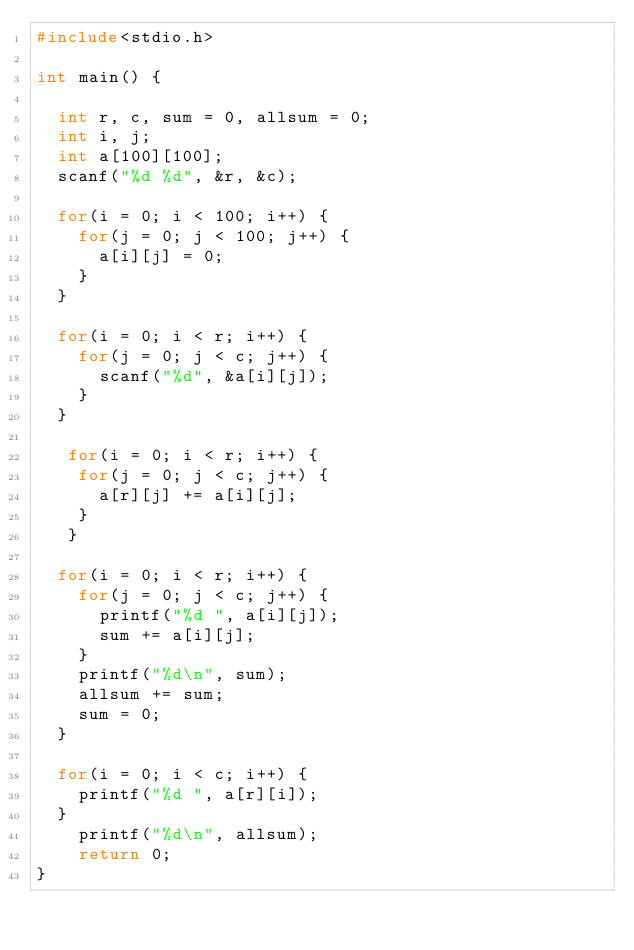Convert code to text. <code><loc_0><loc_0><loc_500><loc_500><_C_>#include<stdio.h>

int main() {

  int r, c, sum = 0, allsum = 0;
  int i, j;
  int a[100][100];
  scanf("%d %d", &r, &c);

  for(i = 0; i < 100; i++) {
    for(j = 0; j < 100; j++) {
      a[i][j] = 0;
    }
  }

  for(i = 0; i < r; i++) {
    for(j = 0; j < c; j++) {
      scanf("%d", &a[i][j]);
    }
  }

   for(i = 0; i < r; i++) {
    for(j = 0; j < c; j++) {
      a[r][j] += a[i][j];
    }
   }

  for(i = 0; i < r; i++) {
    for(j = 0; j < c; j++) {
      printf("%d ", a[i][j]);
      sum += a[i][j];
    }
    printf("%d\n", sum);
    allsum += sum;
    sum = 0;
  }

  for(i = 0; i < c; i++) {
    printf("%d ", a[r][i]);
  }
    printf("%d\n", allsum);
    return 0;
}  </code> 